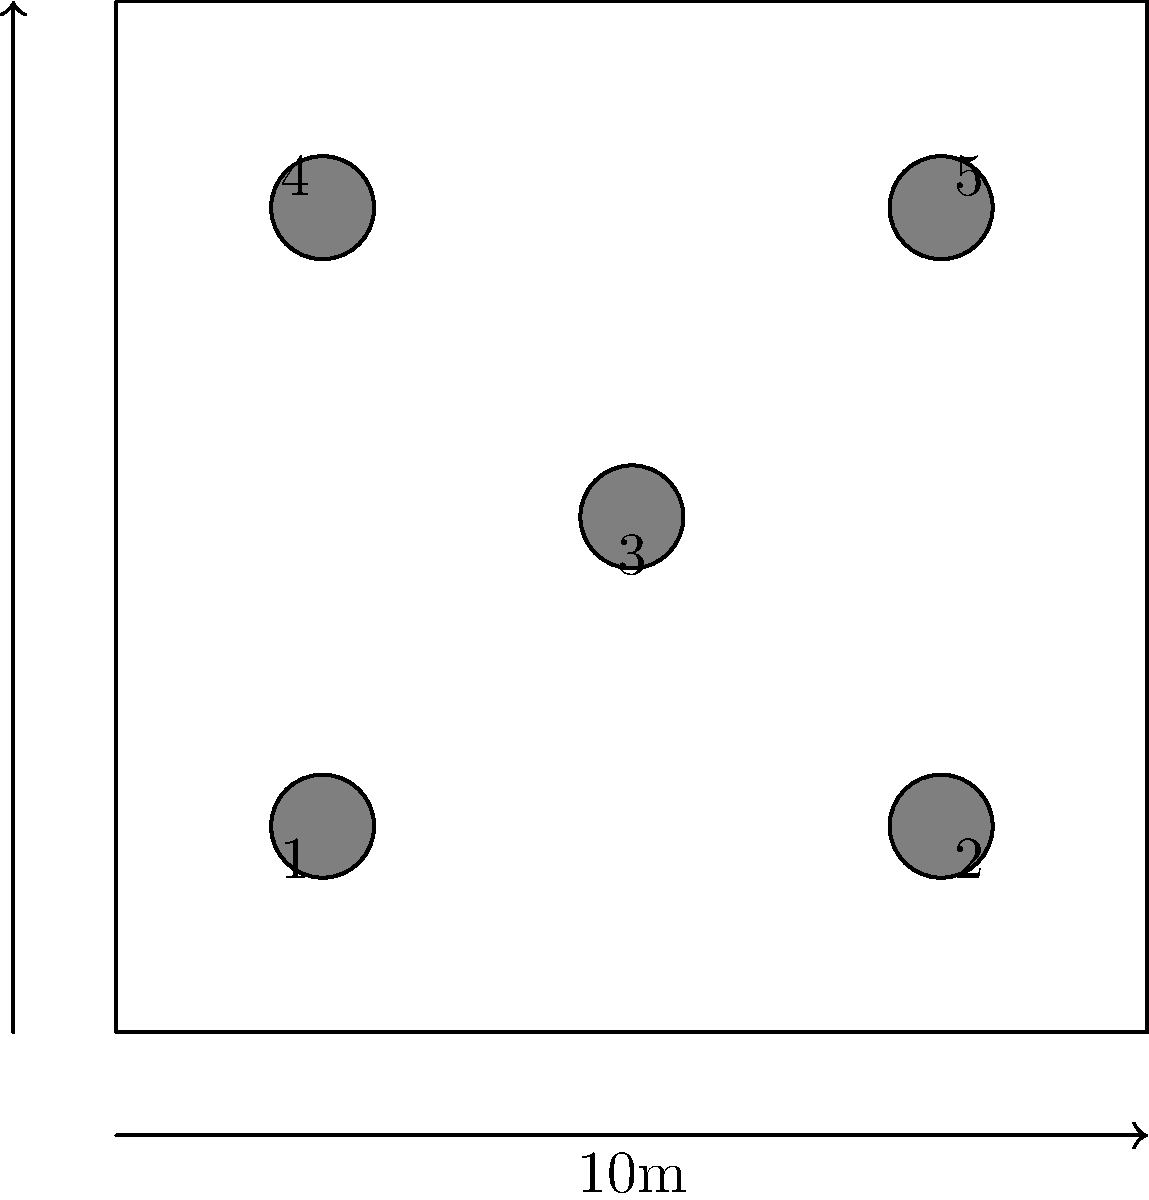In the cemetery plot shown above, five headstones are arranged in a square area of 10m x 10m. If you were to calculate the average distance between all pairs of headstones, which two headstones would contribute the largest distance to this calculation? To determine which two headstones contribute the largest distance, we need to follow these steps:

1. Identify the coordinates of each headstone:
   Headstone 1: (2m, 2m)
   Headstone 2: (8m, 2m)
   Headstone 3: (5m, 5m)
   Headstone 4: (2m, 8m)
   Headstone 5: (8m, 8m)

2. Calculate the distance between each pair of headstones using the distance formula:
   $d = \sqrt{(x_2-x_1)^2 + (y_2-y_1)^2}$

3. Compare all distances:
   1-2: $\sqrt{(8-2)^2 + (2-2)^2} = 6$m
   1-3: $\sqrt{(5-2)^2 + (5-2)^2} = 3\sqrt{2} \approx 4.24$m
   1-4: $\sqrt{(2-2)^2 + (8-2)^2} = 6$m
   1-5: $\sqrt{(8-2)^2 + (8-2)^2} = 6\sqrt{2} \approx 8.49$m
   2-3: $\sqrt{(5-8)^2 + (5-2)^2} = 3\sqrt{2} \approx 4.24$m
   2-4: $\sqrt{(2-8)^2 + (8-2)^2} = 6\sqrt{2} \approx 8.49$m
   2-5: $\sqrt{(8-8)^2 + (8-2)^2} = 6$m
   3-4: $\sqrt{(2-5)^2 + (8-5)^2} = 3\sqrt{2} \approx 4.24$m
   3-5: $\sqrt{(8-5)^2 + (8-5)^2} = 3\sqrt{2} \approx 4.24$m
   4-5: $\sqrt{(8-2)^2 + (8-8)^2} = 6$m

4. Identify the largest distance:
   The largest distance is approximately 8.49m, which occurs between headstones 1-5 and 2-4.

Therefore, the two pairs of headstones that contribute the largest distance are 1-5 and 2-4. Since the question asks for a single pair, we can choose either one.
Answer: Headstones 1 and 5 (or 2 and 4) 